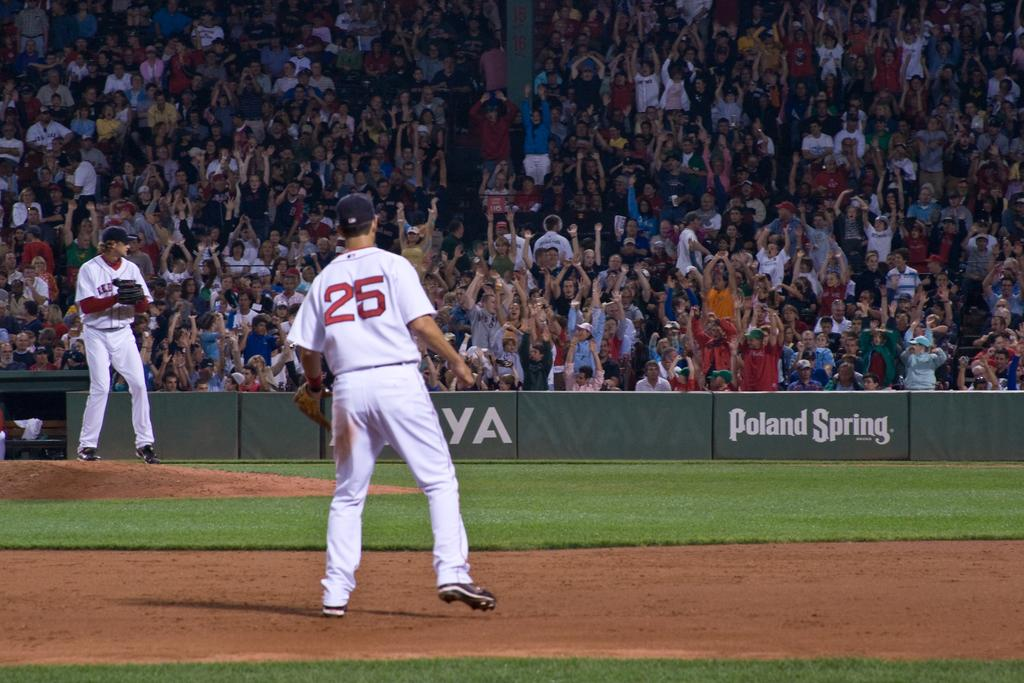<image>
Write a terse but informative summary of the picture. a player that has the number 25 on their jersey 